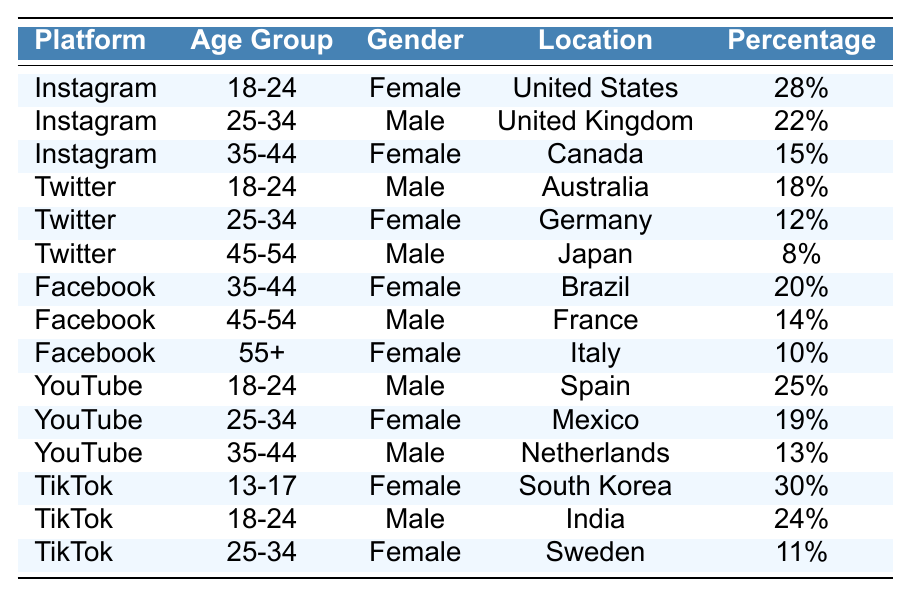What is the highest percentage of followers among all age groups on Instagram? The highest percentage on Instagram is for the age group 18-24, which is 28% of the followers, while the 25-34 age group has 22% and the 35-44 age group has 15%. Thus, 28% is the highest percentage.
Answer: 28% Which social media platform has the largest percentage of followers in the 13-17 age group? TikTok has the largest percentage of followers in the 13-17 age group, with 30%. Other platforms do not have this age group represented.
Answer: TikTok What is the combined percentage of female followers aged 35-44 across all platforms? For the age group 35-44, the female percentages are: 15% on Instagram, 20% on Facebook, and 19% on YouTube. The total is 15 + 20 + 19 = 54%.
Answer: 54% Are there more male than female followers aged 25-34 across all platforms? The percentages for 25-34 age group are: 22% male on Instagram, 12% female on Twitter, 19% female on YouTube, and 11% female on TikTok. Thus, 22% male is higher than the combined 12 + 19 + 11 = 42% female.
Answer: Yes What percentage of total followers are male from Twitter in the 45-54 age group? The percentage of Twitter followers aged 45-54 is 8% male. There are no other age groups or platforms mentioned for males specifically in this age range.
Answer: 8% What is the difference in percentage between the highest female follower percentage and the highest male follower percentage across all platforms? The highest percentage for female followers is 30% (TikTok, age 13-17), and the highest for male followers is 28% (Instagram, age 18-24). The difference is 30 - 28 = 2%.
Answer: 2% Which platform has the least number of female followers in the 55+ age group? The only platform that lists a 55+ age group for female followers is Facebook, which has 10%. No other platforms have reported data for this age group, so it is the least.
Answer: Facebook What is the average percentage of female followers across all platforms? The female percentages are 28% (Instagram 18-24), 15% (Instagram 35-44), 12% (Twitter 25-34), 20% (Facebook 35-44), 14% (Facebook 45-54), 10% (Facebook 55+), 19% (YouTube 25-34), and 30% (TikTok 13-17), 24% (TikTok 18-24), and 11% (TikTok 25-34). The sum is 28 + 15 + 12 + 20 + 14 + 10 + 19 + 30 + 24 + 11 =  188% divided by 10 data points gives an average of 18.8%.
Answer: 18.8% How many platforms have a male follower percentage of 12% or less? On the platforms listed, the percentages of male followers that are 12% or less are as follows: 12% on Twitter for 25-34, and 8% on Twitter for 45-54. Therefore, there are 2 platforms meeting this criterion.
Answer: 2 